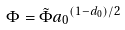Convert formula to latex. <formula><loc_0><loc_0><loc_500><loc_500>\Phi = \tilde { \Phi } { a _ { 0 } } ^ { ( 1 - d _ { 0 } ) / 2 }</formula> 